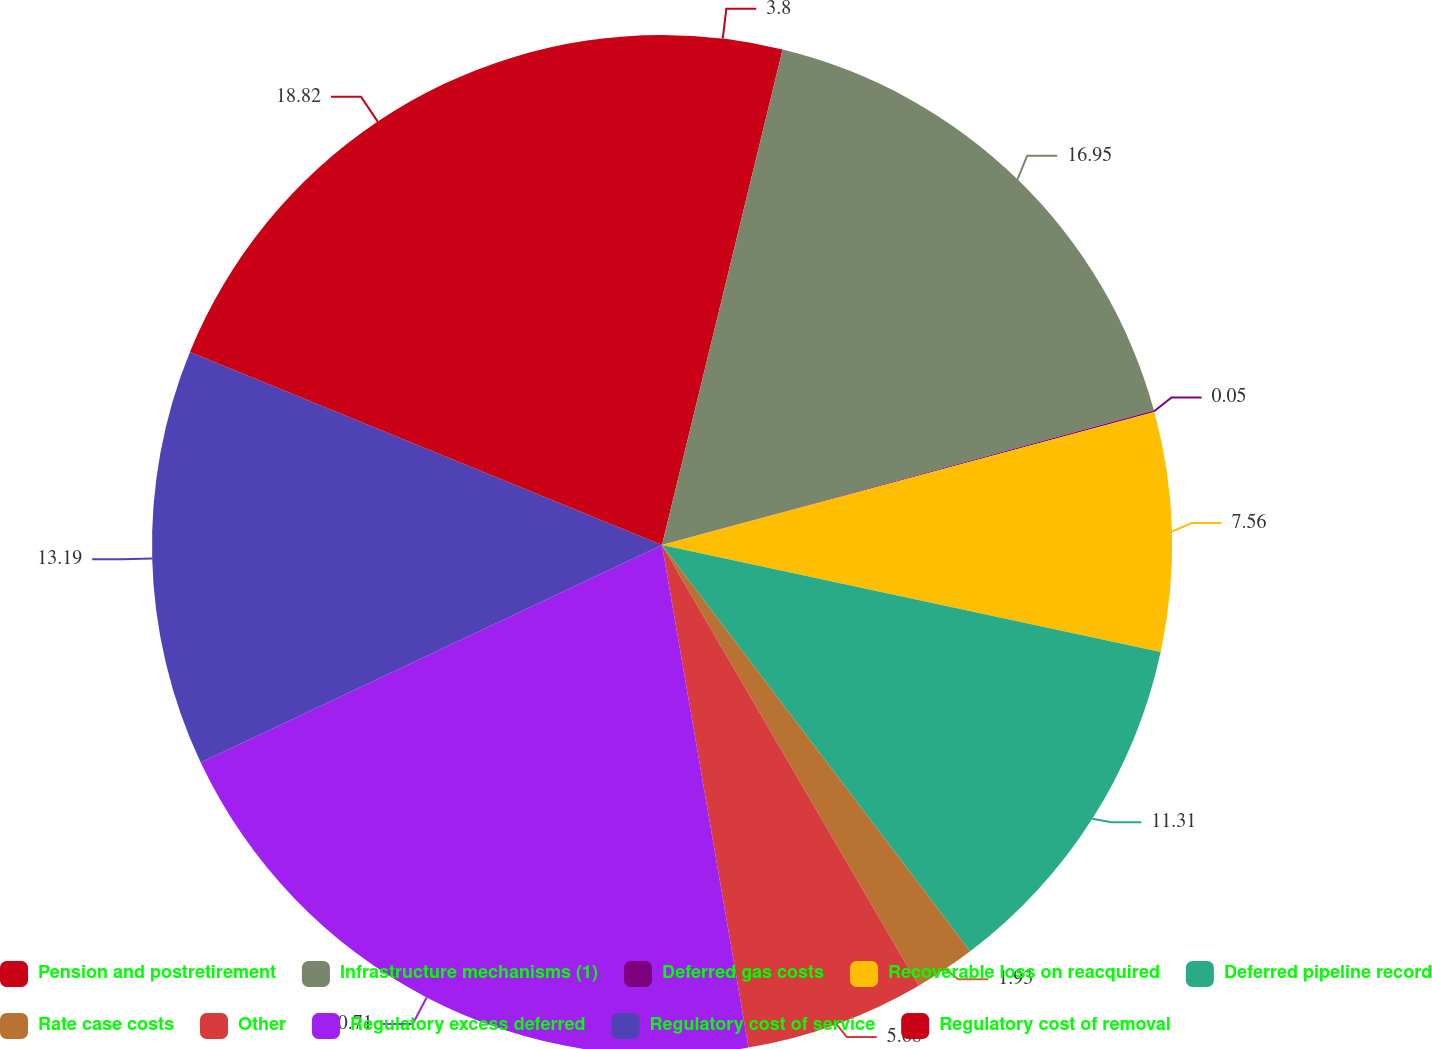<chart> <loc_0><loc_0><loc_500><loc_500><pie_chart><fcel>Pension and postretirement<fcel>Infrastructure mechanisms (1)<fcel>Deferred gas costs<fcel>Recoverable loss on reacquired<fcel>Deferred pipeline record<fcel>Rate case costs<fcel>Other<fcel>Regulatory excess deferred<fcel>Regulatory cost of service<fcel>Regulatory cost of removal<nl><fcel>3.8%<fcel>16.95%<fcel>0.05%<fcel>7.56%<fcel>11.31%<fcel>1.93%<fcel>5.68%<fcel>20.7%<fcel>13.19%<fcel>18.82%<nl></chart> 